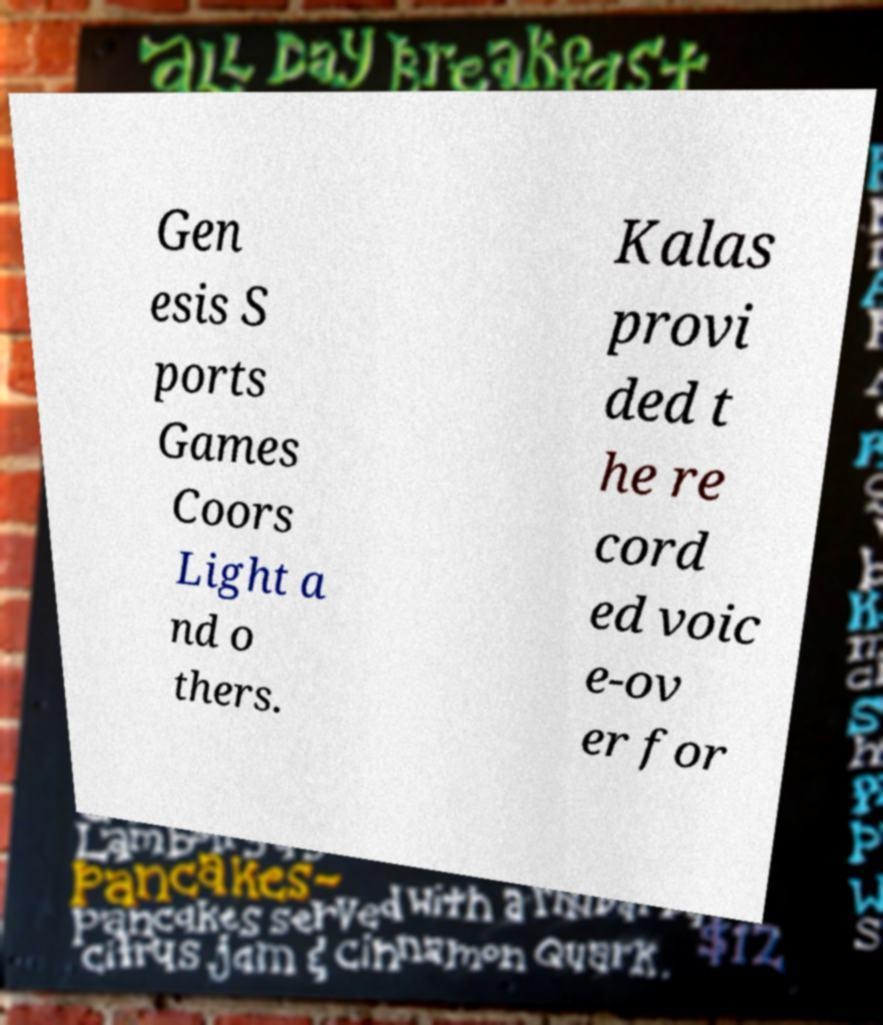For documentation purposes, I need the text within this image transcribed. Could you provide that? Gen esis S ports Games Coors Light a nd o thers. Kalas provi ded t he re cord ed voic e-ov er for 